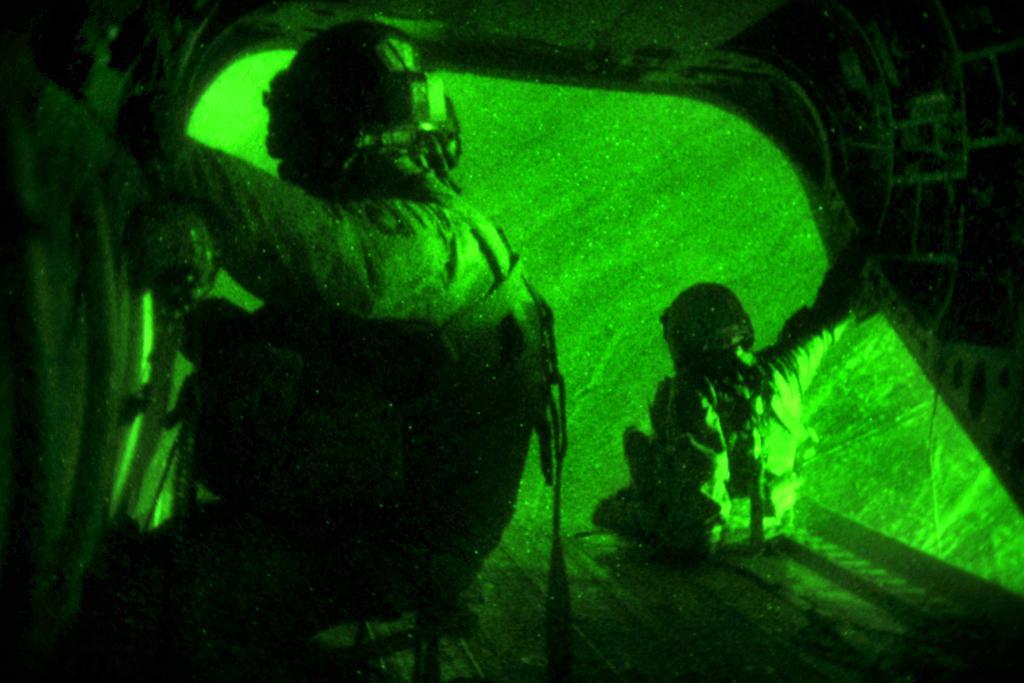How would you summarize this image in a sentence or two? In this image there are two persons who are sitting and they are wearing helmets, and in the background there is green color light and some objects. 